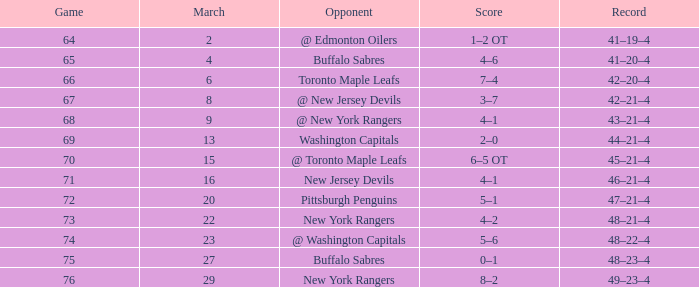Can you give me this table as a dict? {'header': ['Game', 'March', 'Opponent', 'Score', 'Record'], 'rows': [['64', '2', '@ Edmonton Oilers', '1–2 OT', '41–19–4'], ['65', '4', 'Buffalo Sabres', '4–6', '41–20–4'], ['66', '6', 'Toronto Maple Leafs', '7–4', '42–20–4'], ['67', '8', '@ New Jersey Devils', '3–7', '42–21–4'], ['68', '9', '@ New York Rangers', '4–1', '43–21–4'], ['69', '13', 'Washington Capitals', '2–0', '44–21–4'], ['70', '15', '@ Toronto Maple Leafs', '6–5 OT', '45–21–4'], ['71', '16', 'New Jersey Devils', '4–1', '46–21–4'], ['72', '20', 'Pittsburgh Penguins', '5–1', '47–21–4'], ['73', '22', 'New York Rangers', '4–2', '48–21–4'], ['74', '23', '@ Washington Capitals', '5–6', '48–22–4'], ['75', '27', 'Buffalo Sabres', '0–1', '48–23–4'], ['76', '29', 'New York Rangers', '8–2', '49–23–4']]} Which Opponent has a Record of 45–21–4? @ Toronto Maple Leafs. 